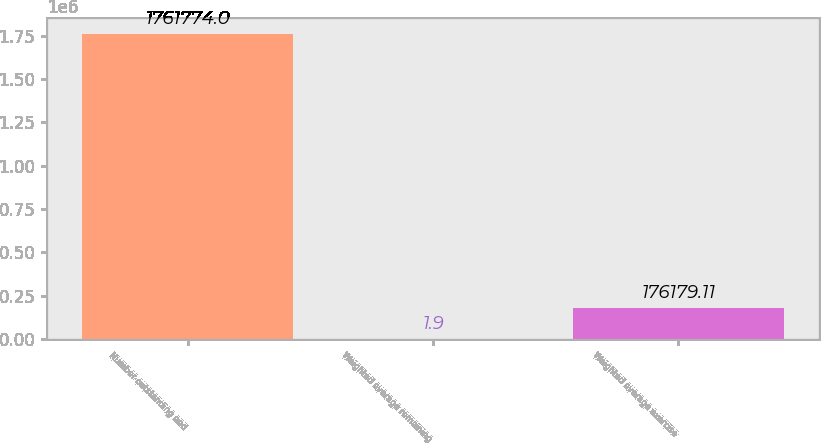Convert chart to OTSL. <chart><loc_0><loc_0><loc_500><loc_500><bar_chart><fcel>Number outstanding and<fcel>Weighted average remaining<fcel>Weighted average exercise<nl><fcel>1.76177e+06<fcel>1.9<fcel>176179<nl></chart> 